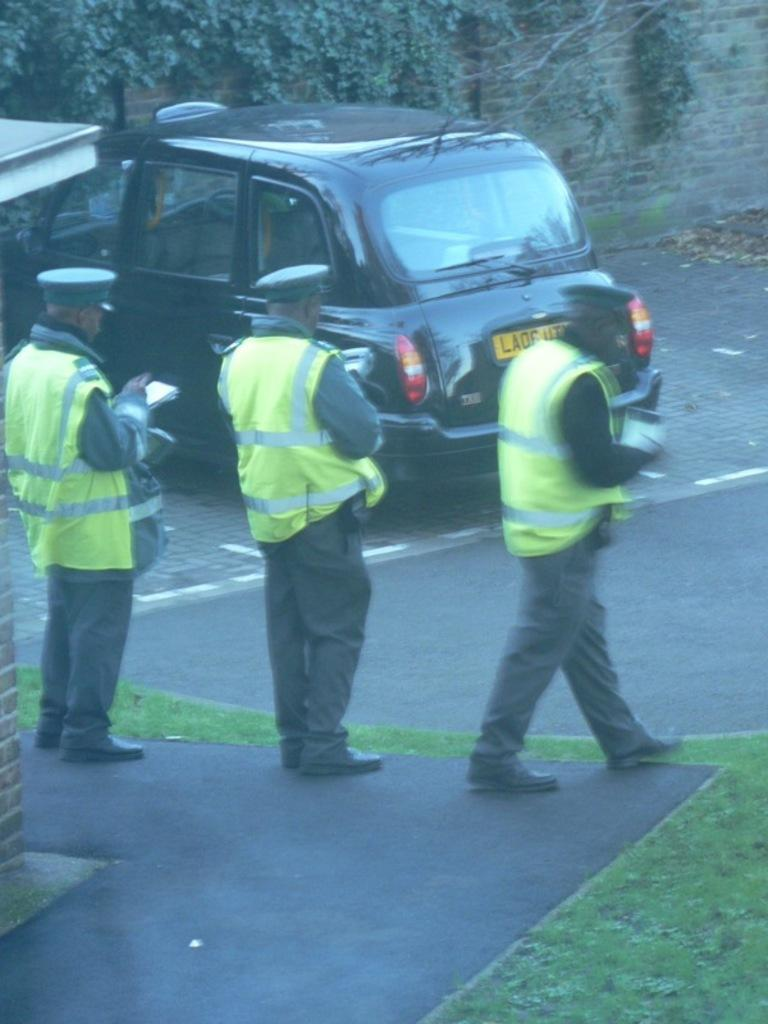What is the main subject of the image? The main subject of the image is a car. Are there any other subjects in the image? Yes, there are 3 policemen in the image. Where are the car and policemen located? The car and policemen are on the road. What is the uncle's wish for the car in the image? There is no uncle present in the image, and therefore no such wish can be attributed to him. 